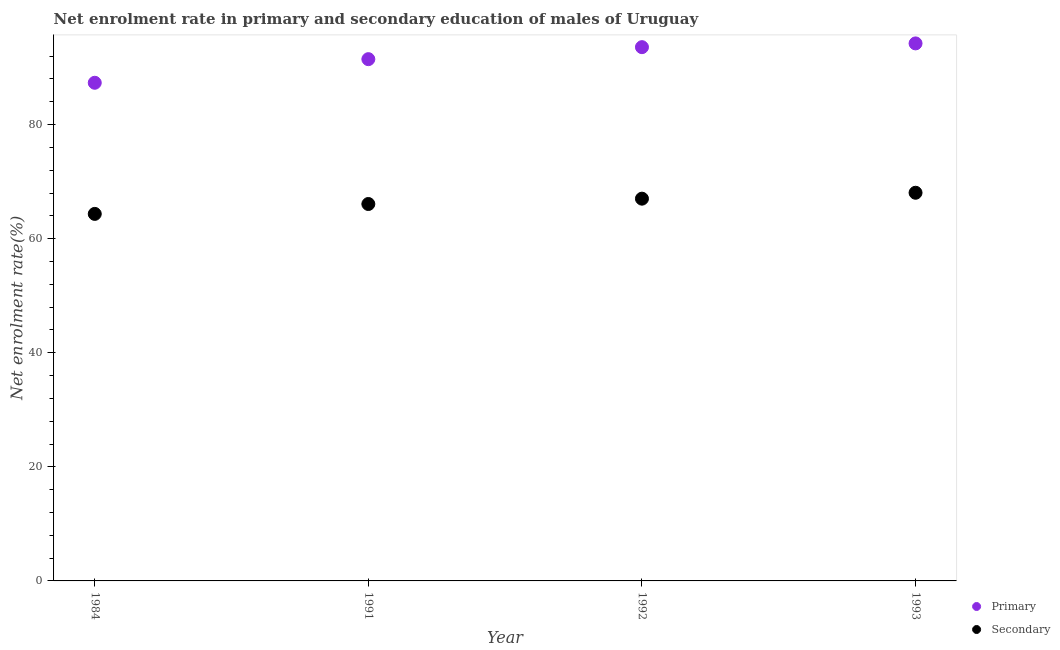How many different coloured dotlines are there?
Your answer should be compact. 2. Is the number of dotlines equal to the number of legend labels?
Offer a very short reply. Yes. What is the enrollment rate in secondary education in 1984?
Ensure brevity in your answer.  64.35. Across all years, what is the maximum enrollment rate in secondary education?
Offer a very short reply. 68.05. Across all years, what is the minimum enrollment rate in secondary education?
Ensure brevity in your answer.  64.35. In which year was the enrollment rate in secondary education maximum?
Your answer should be compact. 1993. In which year was the enrollment rate in primary education minimum?
Provide a succinct answer. 1984. What is the total enrollment rate in secondary education in the graph?
Your response must be concise. 265.49. What is the difference between the enrollment rate in primary education in 1984 and that in 1993?
Your answer should be compact. -6.9. What is the difference between the enrollment rate in secondary education in 1984 and the enrollment rate in primary education in 1991?
Your response must be concise. -27.13. What is the average enrollment rate in primary education per year?
Give a very brief answer. 91.65. In the year 1993, what is the difference between the enrollment rate in primary education and enrollment rate in secondary education?
Make the answer very short. 26.18. In how many years, is the enrollment rate in primary education greater than 12 %?
Make the answer very short. 4. What is the ratio of the enrollment rate in primary education in 1984 to that in 1991?
Ensure brevity in your answer.  0.95. Is the enrollment rate in primary education in 1992 less than that in 1993?
Offer a terse response. Yes. What is the difference between the highest and the second highest enrollment rate in secondary education?
Make the answer very short. 1.04. What is the difference between the highest and the lowest enrollment rate in primary education?
Provide a succinct answer. 6.9. Does the enrollment rate in secondary education monotonically increase over the years?
Your response must be concise. Yes. Is the enrollment rate in primary education strictly greater than the enrollment rate in secondary education over the years?
Make the answer very short. Yes. How many years are there in the graph?
Keep it short and to the point. 4. What is the difference between two consecutive major ticks on the Y-axis?
Give a very brief answer. 20. Are the values on the major ticks of Y-axis written in scientific E-notation?
Offer a very short reply. No. How many legend labels are there?
Provide a short and direct response. 2. What is the title of the graph?
Provide a short and direct response. Net enrolment rate in primary and secondary education of males of Uruguay. What is the label or title of the X-axis?
Make the answer very short. Year. What is the label or title of the Y-axis?
Ensure brevity in your answer.  Net enrolment rate(%). What is the Net enrolment rate(%) of Primary in 1984?
Your answer should be very brief. 87.33. What is the Net enrolment rate(%) of Secondary in 1984?
Provide a succinct answer. 64.35. What is the Net enrolment rate(%) in Primary in 1991?
Ensure brevity in your answer.  91.47. What is the Net enrolment rate(%) in Secondary in 1991?
Ensure brevity in your answer.  66.08. What is the Net enrolment rate(%) in Primary in 1992?
Your response must be concise. 93.58. What is the Net enrolment rate(%) in Secondary in 1992?
Your answer should be compact. 67.02. What is the Net enrolment rate(%) of Primary in 1993?
Your answer should be compact. 94.24. What is the Net enrolment rate(%) in Secondary in 1993?
Offer a terse response. 68.05. Across all years, what is the maximum Net enrolment rate(%) of Primary?
Provide a succinct answer. 94.24. Across all years, what is the maximum Net enrolment rate(%) in Secondary?
Offer a very short reply. 68.05. Across all years, what is the minimum Net enrolment rate(%) in Primary?
Your answer should be compact. 87.33. Across all years, what is the minimum Net enrolment rate(%) of Secondary?
Offer a very short reply. 64.35. What is the total Net enrolment rate(%) in Primary in the graph?
Ensure brevity in your answer.  366.62. What is the total Net enrolment rate(%) in Secondary in the graph?
Make the answer very short. 265.49. What is the difference between the Net enrolment rate(%) of Primary in 1984 and that in 1991?
Ensure brevity in your answer.  -4.14. What is the difference between the Net enrolment rate(%) of Secondary in 1984 and that in 1991?
Make the answer very short. -1.73. What is the difference between the Net enrolment rate(%) in Primary in 1984 and that in 1992?
Ensure brevity in your answer.  -6.24. What is the difference between the Net enrolment rate(%) in Secondary in 1984 and that in 1992?
Offer a very short reply. -2.67. What is the difference between the Net enrolment rate(%) in Primary in 1984 and that in 1993?
Keep it short and to the point. -6.9. What is the difference between the Net enrolment rate(%) in Secondary in 1984 and that in 1993?
Provide a short and direct response. -3.71. What is the difference between the Net enrolment rate(%) in Primary in 1991 and that in 1992?
Provide a succinct answer. -2.1. What is the difference between the Net enrolment rate(%) of Secondary in 1991 and that in 1992?
Your answer should be compact. -0.94. What is the difference between the Net enrolment rate(%) in Primary in 1991 and that in 1993?
Offer a terse response. -2.76. What is the difference between the Net enrolment rate(%) in Secondary in 1991 and that in 1993?
Provide a succinct answer. -1.97. What is the difference between the Net enrolment rate(%) in Primary in 1992 and that in 1993?
Provide a succinct answer. -0.66. What is the difference between the Net enrolment rate(%) in Secondary in 1992 and that in 1993?
Your answer should be compact. -1.04. What is the difference between the Net enrolment rate(%) of Primary in 1984 and the Net enrolment rate(%) of Secondary in 1991?
Offer a very short reply. 21.25. What is the difference between the Net enrolment rate(%) in Primary in 1984 and the Net enrolment rate(%) in Secondary in 1992?
Keep it short and to the point. 20.32. What is the difference between the Net enrolment rate(%) of Primary in 1984 and the Net enrolment rate(%) of Secondary in 1993?
Offer a terse response. 19.28. What is the difference between the Net enrolment rate(%) in Primary in 1991 and the Net enrolment rate(%) in Secondary in 1992?
Make the answer very short. 24.46. What is the difference between the Net enrolment rate(%) in Primary in 1991 and the Net enrolment rate(%) in Secondary in 1993?
Make the answer very short. 23.42. What is the difference between the Net enrolment rate(%) in Primary in 1992 and the Net enrolment rate(%) in Secondary in 1993?
Offer a very short reply. 25.53. What is the average Net enrolment rate(%) in Primary per year?
Keep it short and to the point. 91.65. What is the average Net enrolment rate(%) of Secondary per year?
Provide a short and direct response. 66.37. In the year 1984, what is the difference between the Net enrolment rate(%) of Primary and Net enrolment rate(%) of Secondary?
Ensure brevity in your answer.  22.99. In the year 1991, what is the difference between the Net enrolment rate(%) of Primary and Net enrolment rate(%) of Secondary?
Provide a short and direct response. 25.39. In the year 1992, what is the difference between the Net enrolment rate(%) in Primary and Net enrolment rate(%) in Secondary?
Make the answer very short. 26.56. In the year 1993, what is the difference between the Net enrolment rate(%) of Primary and Net enrolment rate(%) of Secondary?
Provide a succinct answer. 26.18. What is the ratio of the Net enrolment rate(%) in Primary in 1984 to that in 1991?
Keep it short and to the point. 0.95. What is the ratio of the Net enrolment rate(%) of Secondary in 1984 to that in 1991?
Your response must be concise. 0.97. What is the ratio of the Net enrolment rate(%) in Secondary in 1984 to that in 1992?
Ensure brevity in your answer.  0.96. What is the ratio of the Net enrolment rate(%) of Primary in 1984 to that in 1993?
Provide a succinct answer. 0.93. What is the ratio of the Net enrolment rate(%) in Secondary in 1984 to that in 1993?
Your answer should be very brief. 0.95. What is the ratio of the Net enrolment rate(%) of Primary in 1991 to that in 1992?
Keep it short and to the point. 0.98. What is the ratio of the Net enrolment rate(%) in Secondary in 1991 to that in 1992?
Provide a succinct answer. 0.99. What is the ratio of the Net enrolment rate(%) in Primary in 1991 to that in 1993?
Provide a short and direct response. 0.97. What is the ratio of the Net enrolment rate(%) of Primary in 1992 to that in 1993?
Your answer should be compact. 0.99. What is the difference between the highest and the second highest Net enrolment rate(%) in Primary?
Provide a succinct answer. 0.66. What is the difference between the highest and the second highest Net enrolment rate(%) of Secondary?
Offer a terse response. 1.04. What is the difference between the highest and the lowest Net enrolment rate(%) in Primary?
Your response must be concise. 6.9. What is the difference between the highest and the lowest Net enrolment rate(%) of Secondary?
Make the answer very short. 3.71. 